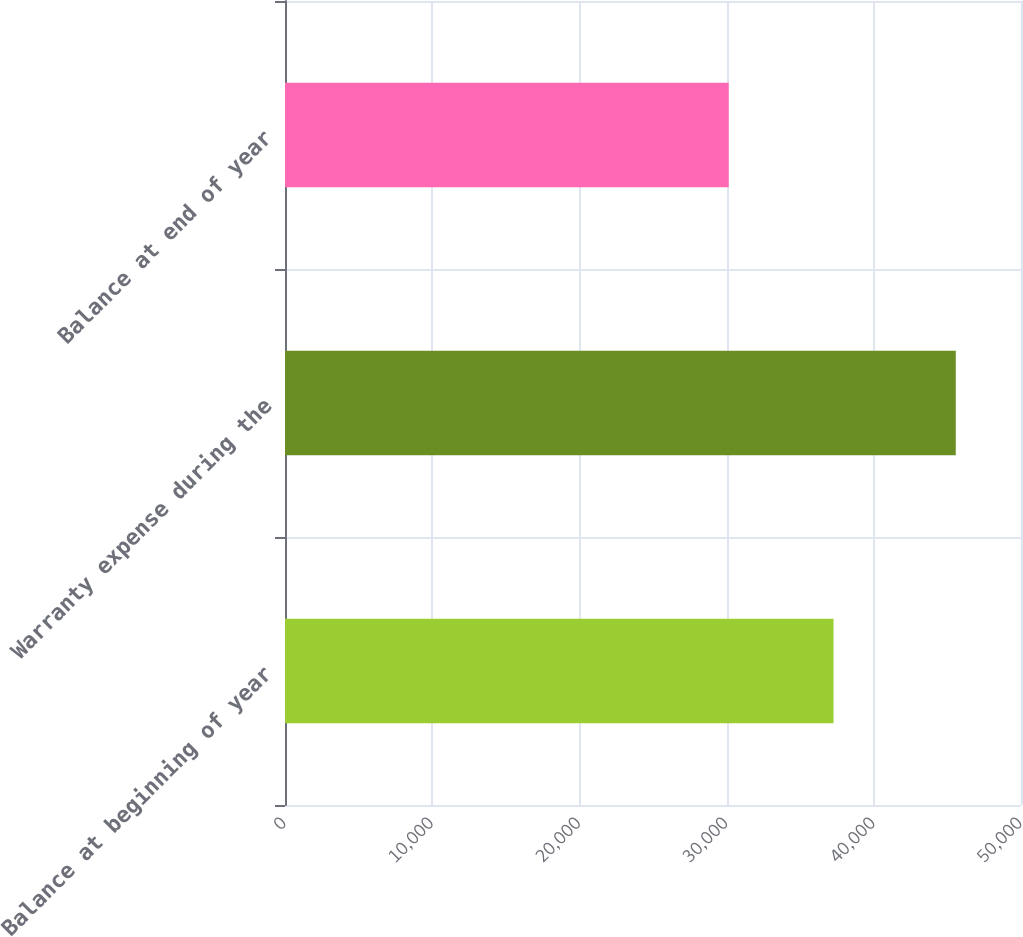Convert chart to OTSL. <chart><loc_0><loc_0><loc_500><loc_500><bar_chart><fcel>Balance at beginning of year<fcel>Warranty expense during the<fcel>Balance at end of year<nl><fcel>37265<fcel>45569<fcel>30144<nl></chart> 